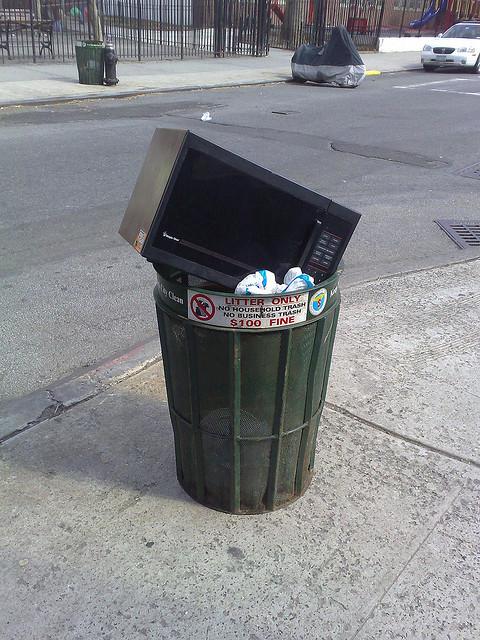What color is the car on the street?
Short answer required. White. What color is the trash can?
Short answer required. Green. Is there a microwave in the trash can?
Write a very short answer. Yes. 